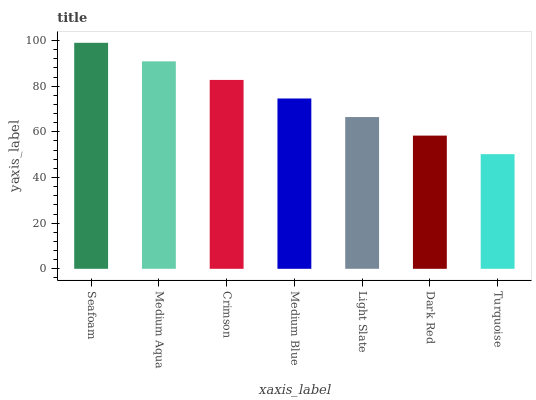Is Turquoise the minimum?
Answer yes or no. Yes. Is Seafoam the maximum?
Answer yes or no. Yes. Is Medium Aqua the minimum?
Answer yes or no. No. Is Medium Aqua the maximum?
Answer yes or no. No. Is Seafoam greater than Medium Aqua?
Answer yes or no. Yes. Is Medium Aqua less than Seafoam?
Answer yes or no. Yes. Is Medium Aqua greater than Seafoam?
Answer yes or no. No. Is Seafoam less than Medium Aqua?
Answer yes or no. No. Is Medium Blue the high median?
Answer yes or no. Yes. Is Medium Blue the low median?
Answer yes or no. Yes. Is Dark Red the high median?
Answer yes or no. No. Is Crimson the low median?
Answer yes or no. No. 